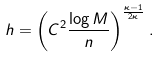Convert formula to latex. <formula><loc_0><loc_0><loc_500><loc_500>h = \left ( C ^ { 2 } \frac { \log M } { n } \right ) ^ { \frac { \kappa - 1 } { 2 \kappa } } .</formula> 